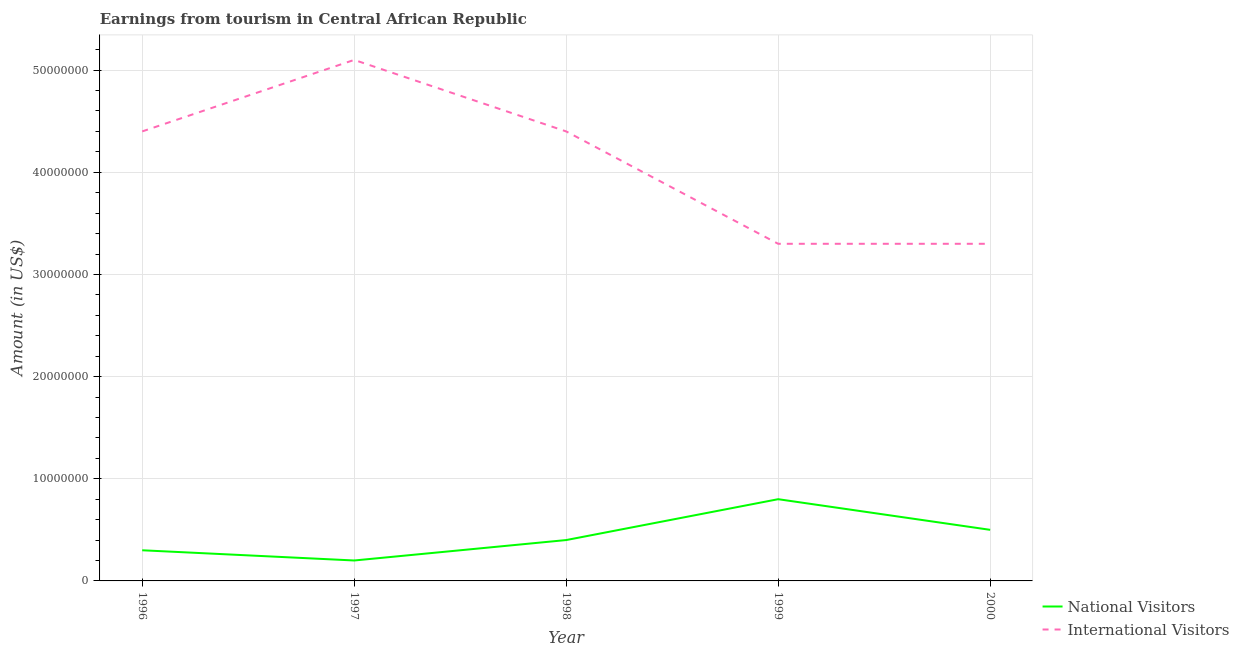How many different coloured lines are there?
Offer a terse response. 2. Does the line corresponding to amount earned from national visitors intersect with the line corresponding to amount earned from international visitors?
Offer a very short reply. No. What is the amount earned from national visitors in 1997?
Make the answer very short. 2.00e+06. Across all years, what is the maximum amount earned from international visitors?
Your answer should be very brief. 5.10e+07. Across all years, what is the minimum amount earned from international visitors?
Ensure brevity in your answer.  3.30e+07. In which year was the amount earned from international visitors minimum?
Keep it short and to the point. 1999. What is the total amount earned from international visitors in the graph?
Keep it short and to the point. 2.05e+08. What is the difference between the amount earned from national visitors in 1997 and that in 1998?
Make the answer very short. -2.00e+06. What is the difference between the amount earned from international visitors in 1999 and the amount earned from national visitors in 1997?
Offer a very short reply. 3.10e+07. What is the average amount earned from national visitors per year?
Provide a succinct answer. 4.40e+06. In the year 1996, what is the difference between the amount earned from national visitors and amount earned from international visitors?
Offer a very short reply. -4.10e+07. Is the amount earned from national visitors in 1996 less than that in 2000?
Ensure brevity in your answer.  Yes. What is the difference between the highest and the second highest amount earned from international visitors?
Provide a succinct answer. 7.00e+06. What is the difference between the highest and the lowest amount earned from national visitors?
Offer a terse response. 6.00e+06. Is the sum of the amount earned from international visitors in 1997 and 1998 greater than the maximum amount earned from national visitors across all years?
Offer a terse response. Yes. Is the amount earned from national visitors strictly greater than the amount earned from international visitors over the years?
Provide a short and direct response. No. Is the amount earned from national visitors strictly less than the amount earned from international visitors over the years?
Provide a short and direct response. Yes. How many lines are there?
Give a very brief answer. 2. Does the graph contain any zero values?
Offer a terse response. No. Does the graph contain grids?
Make the answer very short. Yes. How are the legend labels stacked?
Keep it short and to the point. Vertical. What is the title of the graph?
Give a very brief answer. Earnings from tourism in Central African Republic. What is the Amount (in US$) of International Visitors in 1996?
Your response must be concise. 4.40e+07. What is the Amount (in US$) of National Visitors in 1997?
Offer a terse response. 2.00e+06. What is the Amount (in US$) in International Visitors in 1997?
Provide a short and direct response. 5.10e+07. What is the Amount (in US$) in National Visitors in 1998?
Your answer should be very brief. 4.00e+06. What is the Amount (in US$) in International Visitors in 1998?
Your answer should be very brief. 4.40e+07. What is the Amount (in US$) in International Visitors in 1999?
Your answer should be very brief. 3.30e+07. What is the Amount (in US$) in National Visitors in 2000?
Your answer should be very brief. 5.00e+06. What is the Amount (in US$) of International Visitors in 2000?
Make the answer very short. 3.30e+07. Across all years, what is the maximum Amount (in US$) of National Visitors?
Offer a terse response. 8.00e+06. Across all years, what is the maximum Amount (in US$) in International Visitors?
Offer a very short reply. 5.10e+07. Across all years, what is the minimum Amount (in US$) of National Visitors?
Offer a very short reply. 2.00e+06. Across all years, what is the minimum Amount (in US$) of International Visitors?
Provide a short and direct response. 3.30e+07. What is the total Amount (in US$) of National Visitors in the graph?
Provide a succinct answer. 2.20e+07. What is the total Amount (in US$) in International Visitors in the graph?
Provide a succinct answer. 2.05e+08. What is the difference between the Amount (in US$) of National Visitors in 1996 and that in 1997?
Ensure brevity in your answer.  1.00e+06. What is the difference between the Amount (in US$) in International Visitors in 1996 and that in 1997?
Your response must be concise. -7.00e+06. What is the difference between the Amount (in US$) of National Visitors in 1996 and that in 1999?
Provide a succinct answer. -5.00e+06. What is the difference between the Amount (in US$) of International Visitors in 1996 and that in 1999?
Give a very brief answer. 1.10e+07. What is the difference between the Amount (in US$) of International Visitors in 1996 and that in 2000?
Make the answer very short. 1.10e+07. What is the difference between the Amount (in US$) in National Visitors in 1997 and that in 1998?
Make the answer very short. -2.00e+06. What is the difference between the Amount (in US$) of International Visitors in 1997 and that in 1998?
Offer a terse response. 7.00e+06. What is the difference between the Amount (in US$) of National Visitors in 1997 and that in 1999?
Provide a short and direct response. -6.00e+06. What is the difference between the Amount (in US$) of International Visitors in 1997 and that in 1999?
Your response must be concise. 1.80e+07. What is the difference between the Amount (in US$) of National Visitors in 1997 and that in 2000?
Make the answer very short. -3.00e+06. What is the difference between the Amount (in US$) of International Visitors in 1997 and that in 2000?
Your response must be concise. 1.80e+07. What is the difference between the Amount (in US$) of National Visitors in 1998 and that in 1999?
Your response must be concise. -4.00e+06. What is the difference between the Amount (in US$) in International Visitors in 1998 and that in 1999?
Give a very brief answer. 1.10e+07. What is the difference between the Amount (in US$) in National Visitors in 1998 and that in 2000?
Ensure brevity in your answer.  -1.00e+06. What is the difference between the Amount (in US$) of International Visitors in 1998 and that in 2000?
Keep it short and to the point. 1.10e+07. What is the difference between the Amount (in US$) of International Visitors in 1999 and that in 2000?
Ensure brevity in your answer.  0. What is the difference between the Amount (in US$) of National Visitors in 1996 and the Amount (in US$) of International Visitors in 1997?
Offer a very short reply. -4.80e+07. What is the difference between the Amount (in US$) in National Visitors in 1996 and the Amount (in US$) in International Visitors in 1998?
Offer a terse response. -4.10e+07. What is the difference between the Amount (in US$) of National Visitors in 1996 and the Amount (in US$) of International Visitors in 1999?
Your answer should be very brief. -3.00e+07. What is the difference between the Amount (in US$) of National Visitors in 1996 and the Amount (in US$) of International Visitors in 2000?
Your answer should be compact. -3.00e+07. What is the difference between the Amount (in US$) of National Visitors in 1997 and the Amount (in US$) of International Visitors in 1998?
Your answer should be compact. -4.20e+07. What is the difference between the Amount (in US$) of National Visitors in 1997 and the Amount (in US$) of International Visitors in 1999?
Your answer should be compact. -3.10e+07. What is the difference between the Amount (in US$) in National Visitors in 1997 and the Amount (in US$) in International Visitors in 2000?
Your response must be concise. -3.10e+07. What is the difference between the Amount (in US$) in National Visitors in 1998 and the Amount (in US$) in International Visitors in 1999?
Give a very brief answer. -2.90e+07. What is the difference between the Amount (in US$) of National Visitors in 1998 and the Amount (in US$) of International Visitors in 2000?
Your answer should be compact. -2.90e+07. What is the difference between the Amount (in US$) of National Visitors in 1999 and the Amount (in US$) of International Visitors in 2000?
Your answer should be very brief. -2.50e+07. What is the average Amount (in US$) in National Visitors per year?
Provide a short and direct response. 4.40e+06. What is the average Amount (in US$) in International Visitors per year?
Ensure brevity in your answer.  4.10e+07. In the year 1996, what is the difference between the Amount (in US$) of National Visitors and Amount (in US$) of International Visitors?
Keep it short and to the point. -4.10e+07. In the year 1997, what is the difference between the Amount (in US$) of National Visitors and Amount (in US$) of International Visitors?
Offer a terse response. -4.90e+07. In the year 1998, what is the difference between the Amount (in US$) of National Visitors and Amount (in US$) of International Visitors?
Your response must be concise. -4.00e+07. In the year 1999, what is the difference between the Amount (in US$) of National Visitors and Amount (in US$) of International Visitors?
Ensure brevity in your answer.  -2.50e+07. In the year 2000, what is the difference between the Amount (in US$) of National Visitors and Amount (in US$) of International Visitors?
Keep it short and to the point. -2.80e+07. What is the ratio of the Amount (in US$) in National Visitors in 1996 to that in 1997?
Your answer should be compact. 1.5. What is the ratio of the Amount (in US$) of International Visitors in 1996 to that in 1997?
Your response must be concise. 0.86. What is the ratio of the Amount (in US$) of National Visitors in 1996 to that in 1998?
Keep it short and to the point. 0.75. What is the ratio of the Amount (in US$) in International Visitors in 1997 to that in 1998?
Make the answer very short. 1.16. What is the ratio of the Amount (in US$) in National Visitors in 1997 to that in 1999?
Your answer should be very brief. 0.25. What is the ratio of the Amount (in US$) of International Visitors in 1997 to that in 1999?
Your response must be concise. 1.55. What is the ratio of the Amount (in US$) in International Visitors in 1997 to that in 2000?
Your response must be concise. 1.55. What is the ratio of the Amount (in US$) in National Visitors in 1998 to that in 1999?
Ensure brevity in your answer.  0.5. What is the ratio of the Amount (in US$) in International Visitors in 1998 to that in 1999?
Keep it short and to the point. 1.33. What is the ratio of the Amount (in US$) in National Visitors in 1998 to that in 2000?
Keep it short and to the point. 0.8. What is the ratio of the Amount (in US$) of International Visitors in 1998 to that in 2000?
Keep it short and to the point. 1.33. What is the ratio of the Amount (in US$) in National Visitors in 1999 to that in 2000?
Offer a terse response. 1.6. What is the ratio of the Amount (in US$) of International Visitors in 1999 to that in 2000?
Offer a terse response. 1. What is the difference between the highest and the second highest Amount (in US$) in International Visitors?
Make the answer very short. 7.00e+06. What is the difference between the highest and the lowest Amount (in US$) of National Visitors?
Your response must be concise. 6.00e+06. What is the difference between the highest and the lowest Amount (in US$) in International Visitors?
Keep it short and to the point. 1.80e+07. 